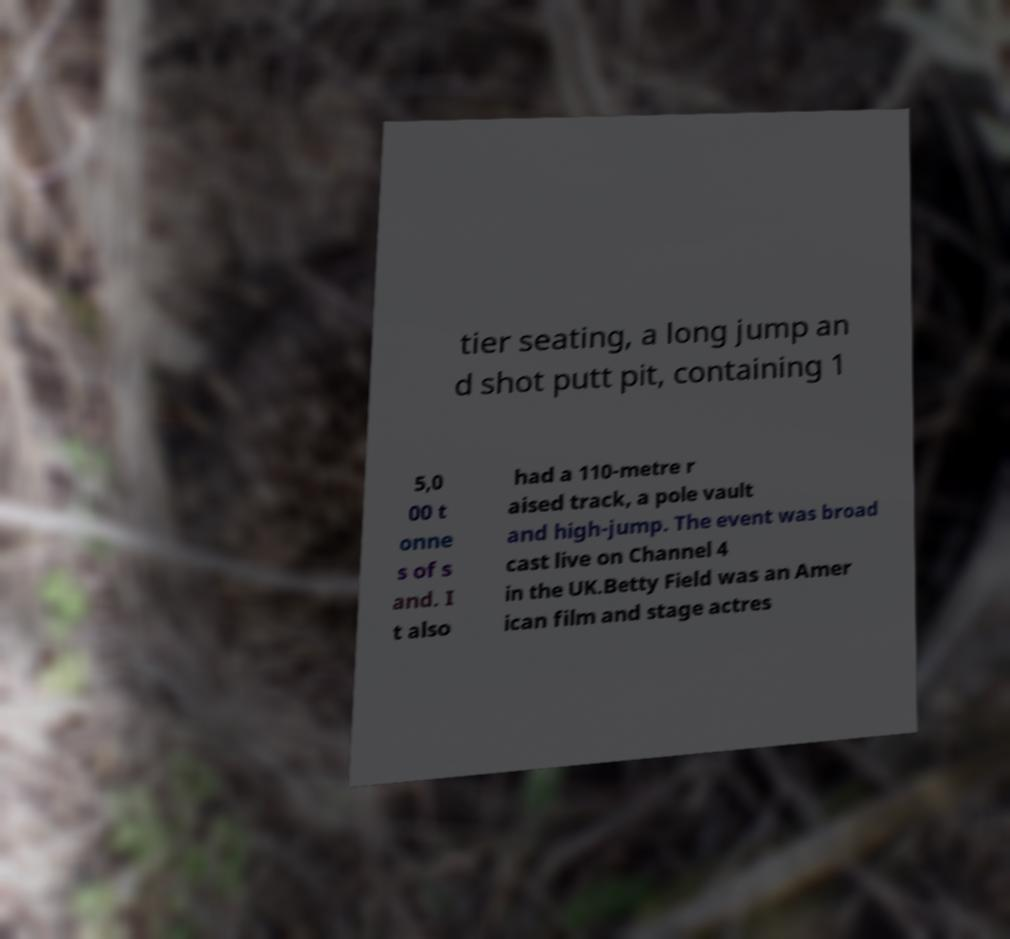Could you extract and type out the text from this image? tier seating, a long jump an d shot putt pit, containing 1 5,0 00 t onne s of s and. I t also had a 110-metre r aised track, a pole vault and high-jump. The event was broad cast live on Channel 4 in the UK.Betty Field was an Amer ican film and stage actres 